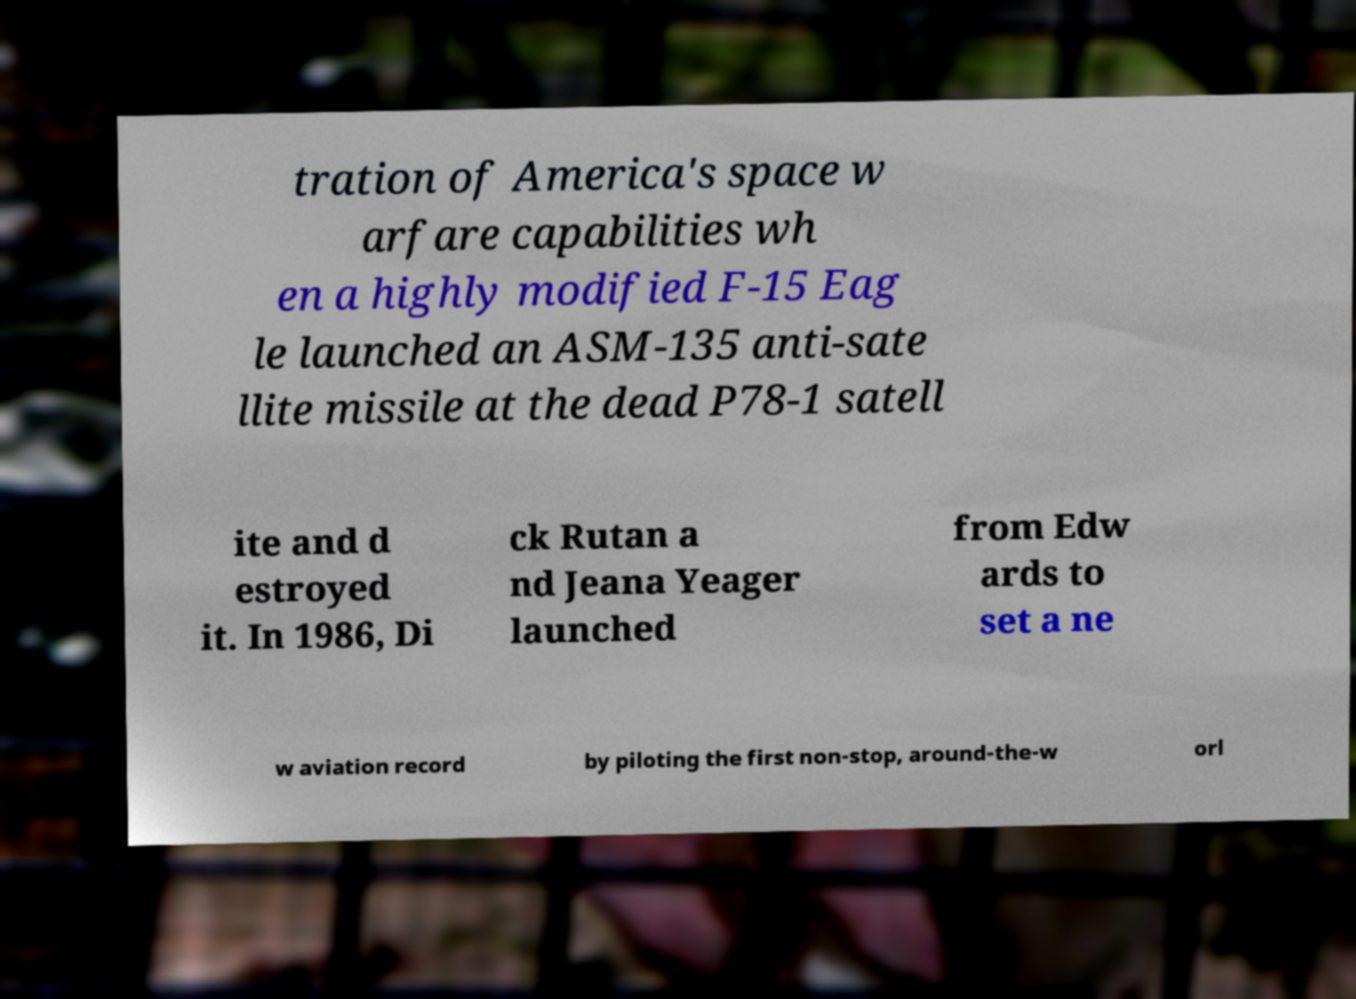Can you accurately transcribe the text from the provided image for me? tration of America's space w arfare capabilities wh en a highly modified F-15 Eag le launched an ASM-135 anti-sate llite missile at the dead P78-1 satell ite and d estroyed it. In 1986, Di ck Rutan a nd Jeana Yeager launched from Edw ards to set a ne w aviation record by piloting the first non-stop, around-the-w orl 